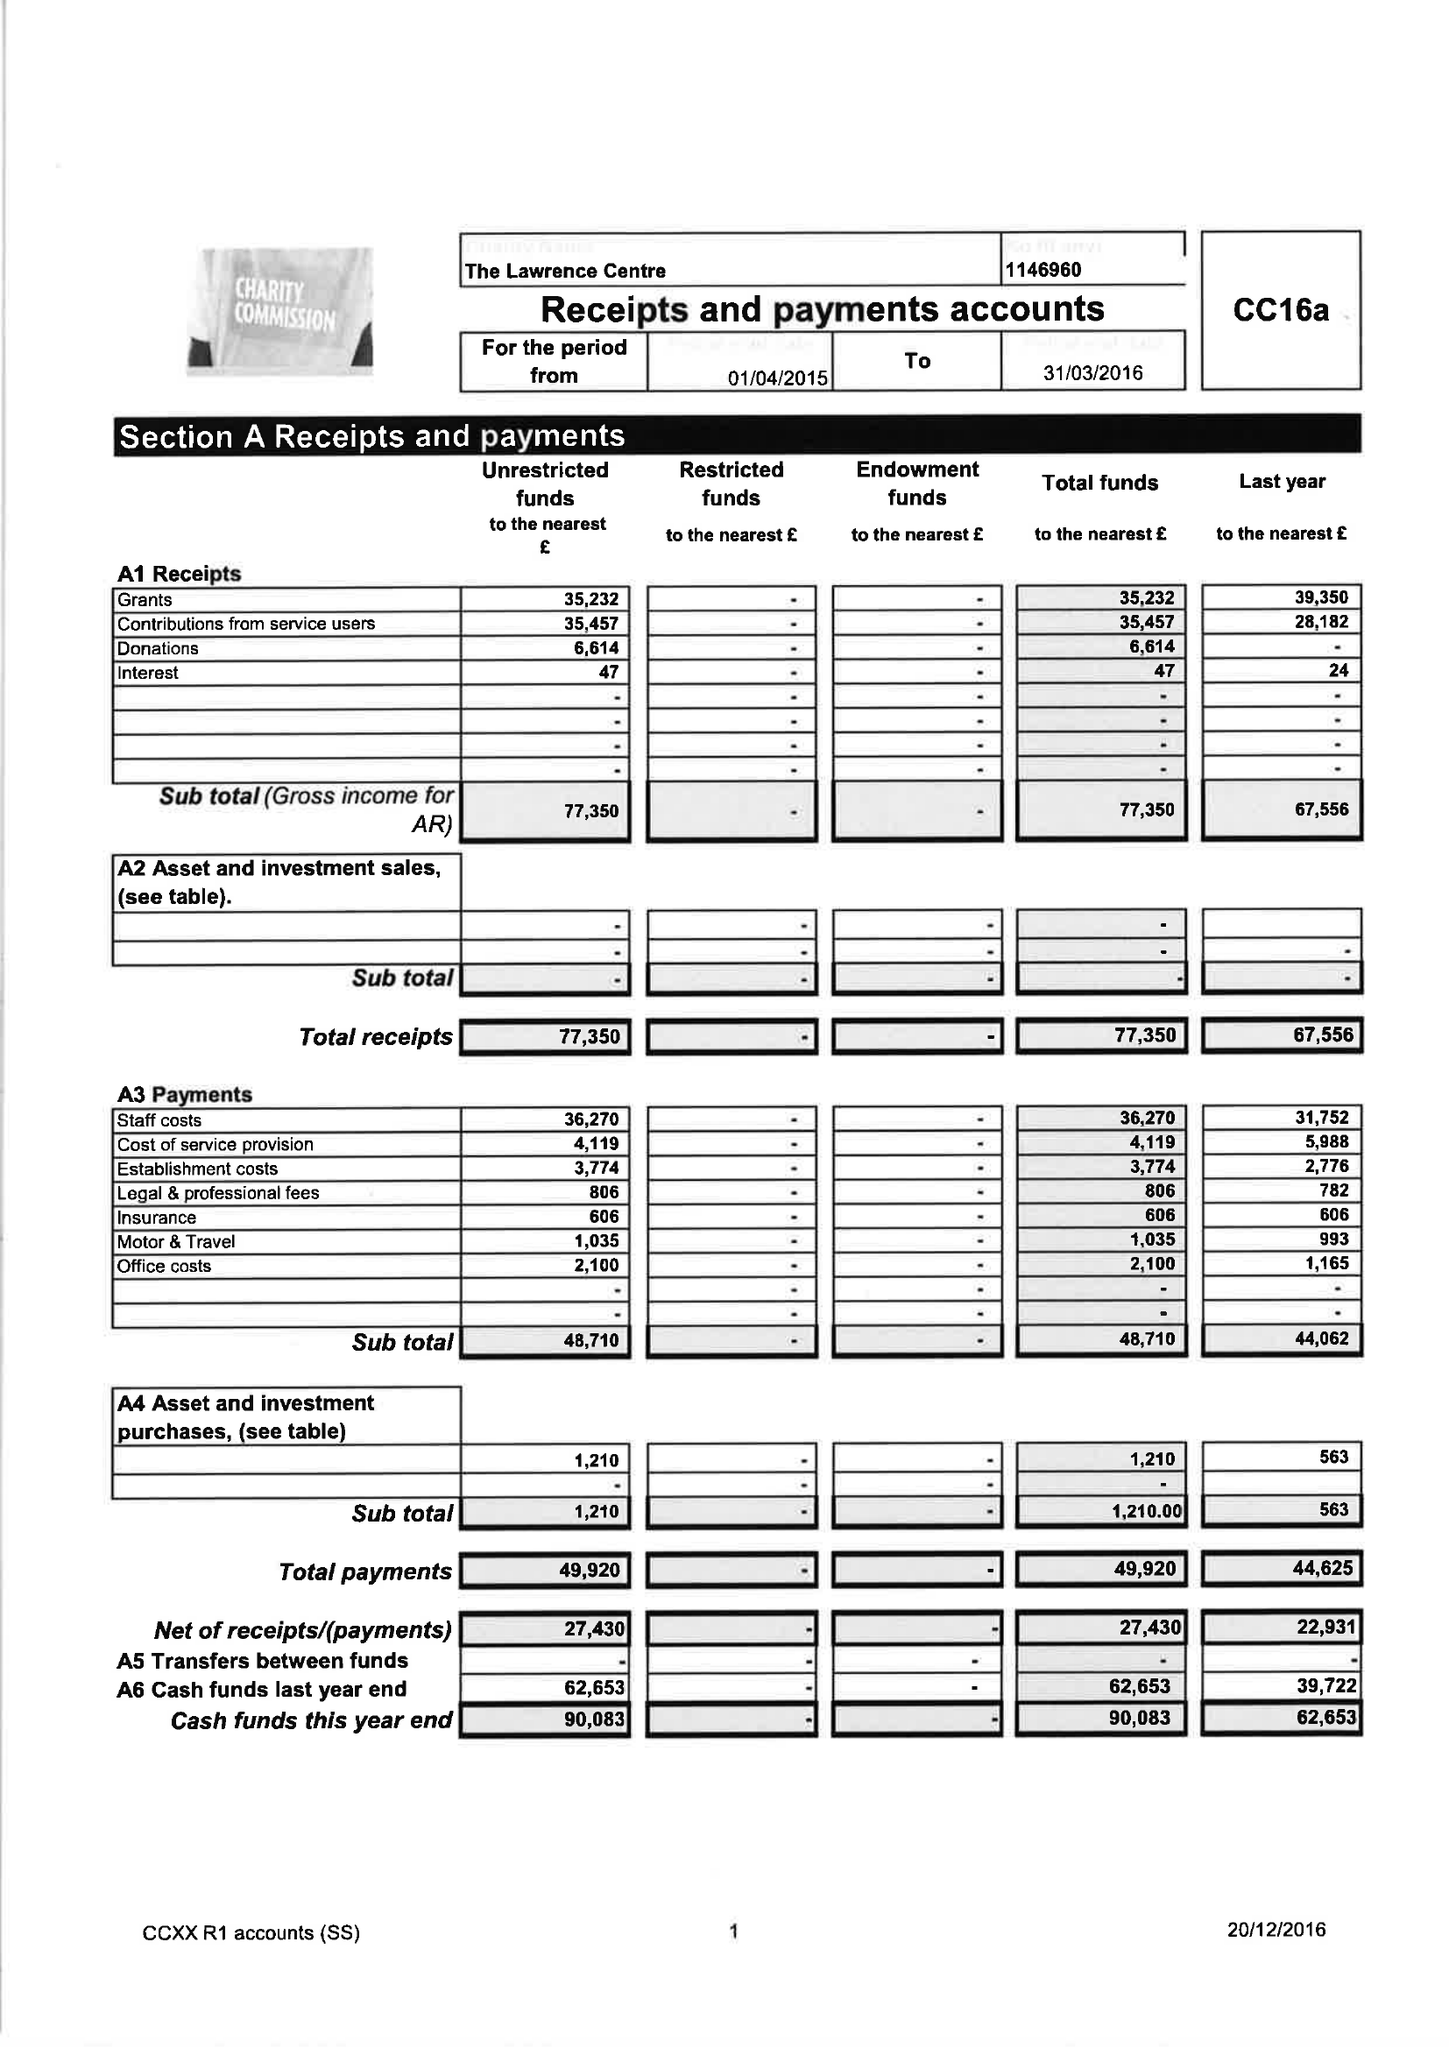What is the value for the report_date?
Answer the question using a single word or phrase. 2016-03-31 